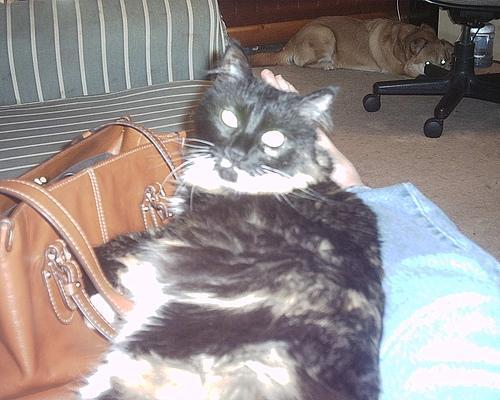How many animals are in the picture?
Give a very brief answer. 2. How many purses are in the picture?
Give a very brief answer. 1. How many ears does the dog have?
Give a very brief answer. 2. 